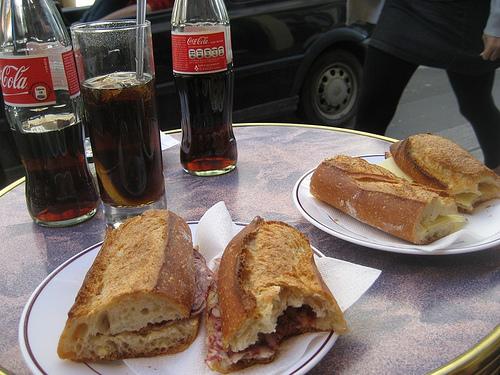What is in the sandwich?
Short answer required. Salami. Have the diners started their lunch?
Answer briefly. Yes. How many cola bottles are there?
Answer briefly. 2. 